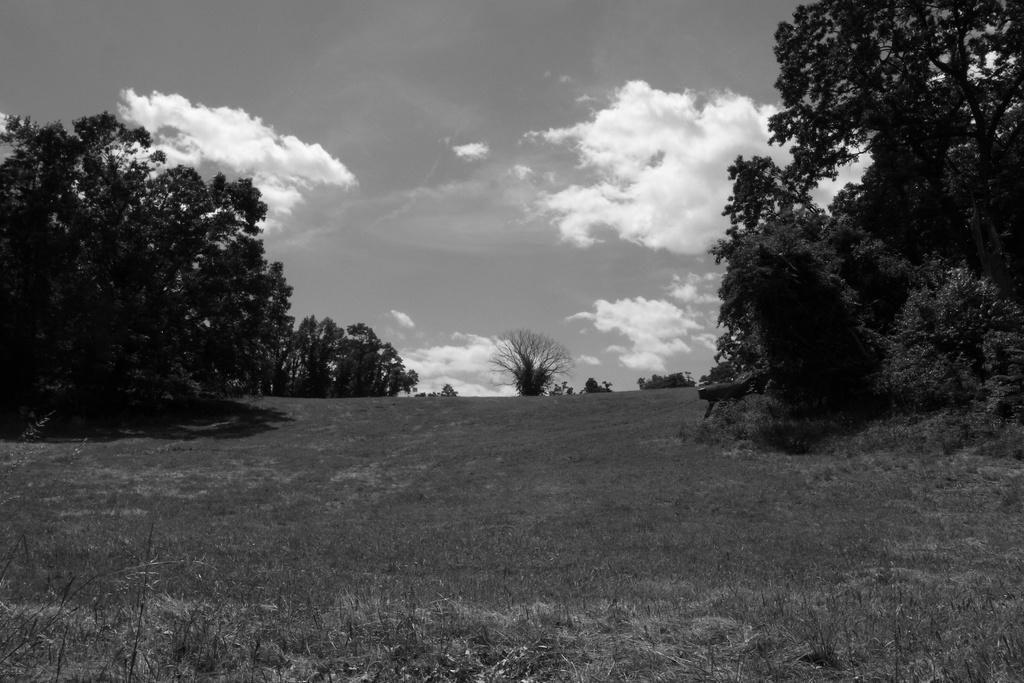How would you summarize this image in a sentence or two? In this image I can see an open cross ground in the center and in the background I can see number of trees, clouds and the sky. I can also see this image is black and white in color. 